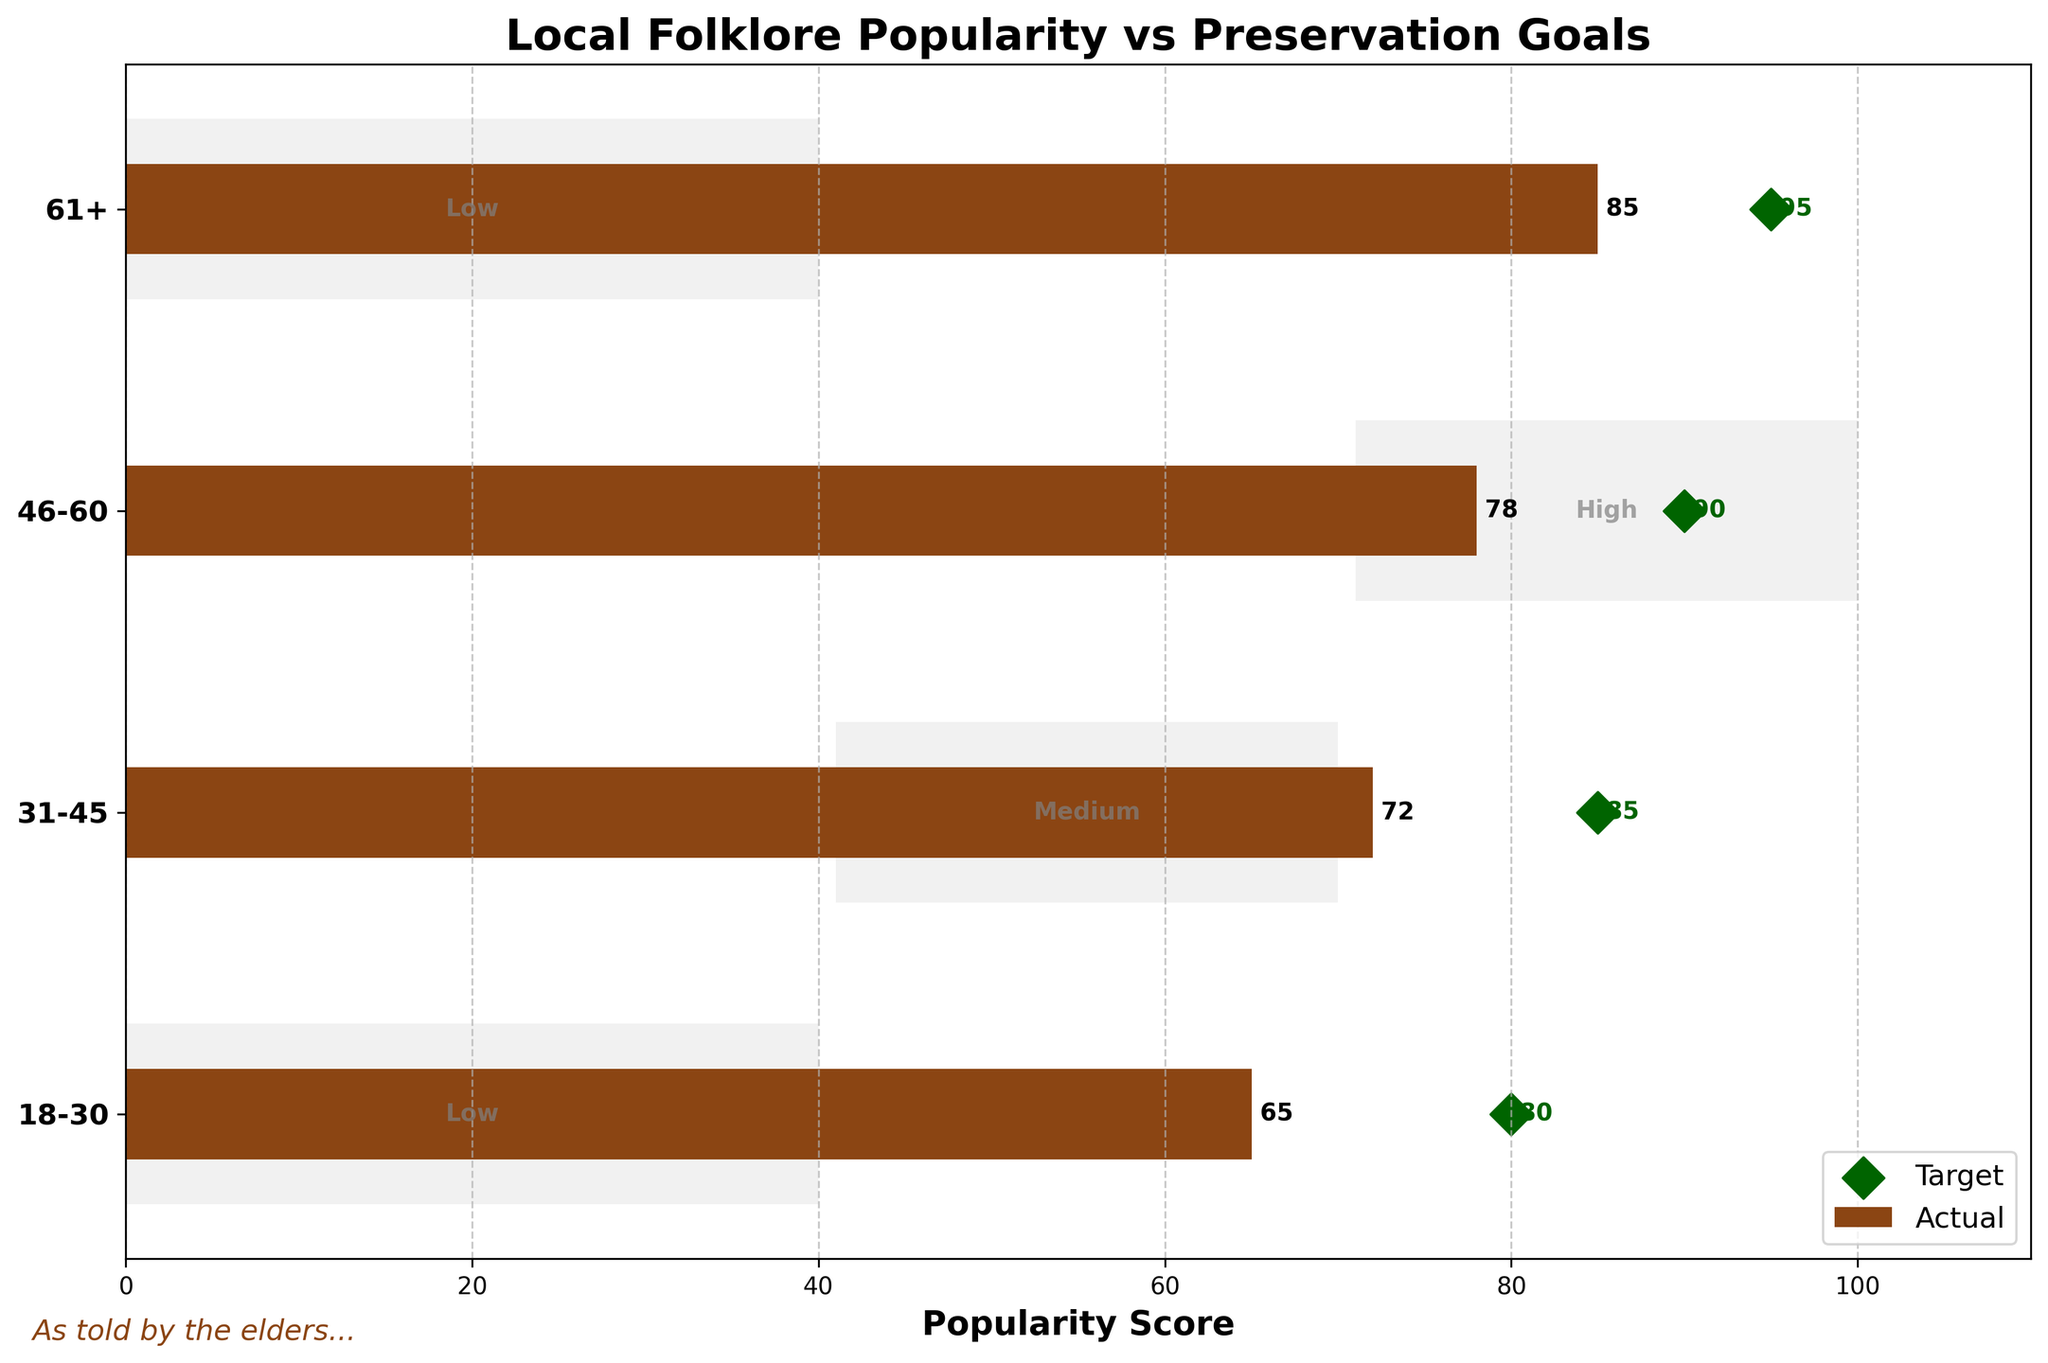What is the popularity score of the folklore among people aged 61+? The bar for the age group 61+ indicates a popularity score of 85.
Answer: 85 What is the target popularity score for the age group 46-60? The diamond marker for the age group 46-60 indicates a target popularity score of 90.
Answer: 90 How does the actual popularity of folklore for the 31-45 age group compare to its target? The bar for the 31-45 age group shows an actual popularity score of 72, while the diamond marker shows a target score of 85. The actual score is 13 points lower than the target.
Answer: 13 points lower Which age group has the highest actual popularity score for local folklore? The bars indicate actual popularity scores, with the highest bar being 85 for the age group 61+.
Answer: 61+ What is the average target popularity score across all age groups? The target scores are 80, 85, 90, and 95. The average can be calculated as (80 + 85 + 90 + 95) / 4 = 87.5.
Answer: 87.5 Which age group's actual popularity score falls within the 'High' range? The 'High' range is from 71 to 100. The actual scores are 65, 72, 78, and 85. Only the age groups 46-60 (78) and 61+ (85) fall within this range.
Answer: 46-60 and 61+ In which age group is the gap between actual and target popularity the smallest? The gaps are 15 for 18-30 (80 - 65), 13 for 31-45 (85 - 72), 12 for 46-60 (90 - 78), and 10 for 61+ (95 - 85). The smallest gap is 10 for the age group 61+.
Answer: 61+ What is the difference between the highest target score and the lowest actual score? The highest target score is 95 (61+), and the lowest actual score is 65 (18-30). The difference is 95 - 65 = 30.
Answer: 30 Which age group meets its target popularity range (either low, medium, or high)? None of the age groups have an actual score that meets the target scores set at 80, 85, 90, and 95 respectively. Each group's actual score is below its target.
Answer: None 